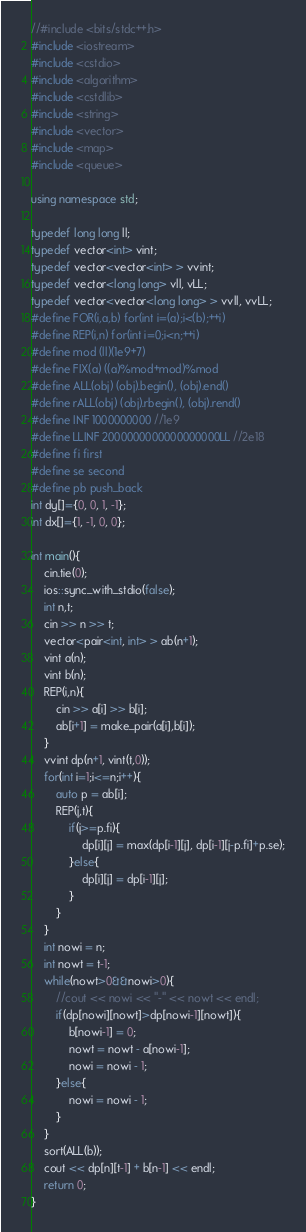Convert code to text. <code><loc_0><loc_0><loc_500><loc_500><_C++_>//#include <bits/stdc++.h>
#include <iostream>
#include <cstdio>
#include <algorithm>
#include <cstdlib>
#include <string>
#include <vector>
#include <map>
#include <queue>

using namespace std;

typedef long long ll;
typedef vector<int> vint;
typedef vector<vector<int> > vvint;
typedef vector<long long> vll, vLL;
typedef vector<vector<long long> > vvll, vvLL;
#define FOR(i,a,b) for(int i=(a);i<(b);++i)
#define REP(i,n) for(int i=0;i<n;++i)
#define mod (ll)(1e9+7)
#define FIX(a) ((a)%mod+mod)%mod
#define ALL(obj) (obj).begin(), (obj).end()
#define rALL(obj) (obj).rbegin(), (obj).rend()
#define INF 1000000000 //1e9
#define LLINF 2000000000000000000LL //2e18
#define fi first
#define se second
#define pb push_back
int dy[]={0, 0, 1, -1};
int dx[]={1, -1, 0, 0};

int main(){
    cin.tie(0);
    ios::sync_with_stdio(false);
    int n,t;
    cin >> n >> t;
    vector<pair<int, int> > ab(n+1);
    vint a(n);
    vint b(n);
    REP(i,n){
        cin >> a[i] >> b[i];
        ab[i+1] = make_pair(a[i],b[i]);
    }
    vvint dp(n+1, vint(t,0));
    for(int i=1;i<=n;i++){
        auto p = ab[i];
        REP(j,t){
            if(j>=p.fi){
                dp[i][j] = max(dp[i-1][j], dp[i-1][j-p.fi]+p.se);
            }else{
                dp[i][j] = dp[i-1][j];
            }
        }
    }
    int nowi = n;
    int nowt = t-1;
    while(nowt>0&&nowi>0){
        //cout << nowi << "-" << nowt << endl;
        if(dp[nowi][nowt]>dp[nowi-1][nowt]){
            b[nowi-1] = 0;
            nowt = nowt - a[nowi-1];
            nowi = nowi - 1; 
        }else{
            nowi = nowi - 1;
        }
    }
    sort(ALL(b));
    cout << dp[n][t-1] + b[n-1] << endl;
    return 0;
}</code> 